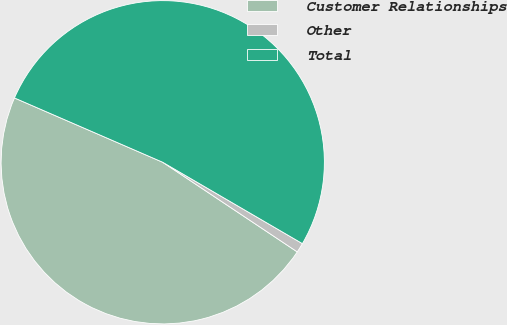Convert chart. <chart><loc_0><loc_0><loc_500><loc_500><pie_chart><fcel>Customer Relationships<fcel>Other<fcel>Total<nl><fcel>47.16%<fcel>0.96%<fcel>51.88%<nl></chart> 